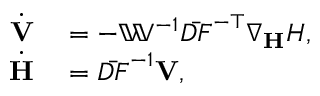Convert formula to latex. <formula><loc_0><loc_0><loc_500><loc_500>\begin{array} { r l } { \dot { \mathbf V } } & = - { \mathbb { W } } ^ { - 1 } \bar { D F } ^ { - \top } \nabla _ { H } H , } \\ { \dot { \mathbf H } } & = \bar { D F } ^ { - 1 } { V } , } \end{array}</formula> 